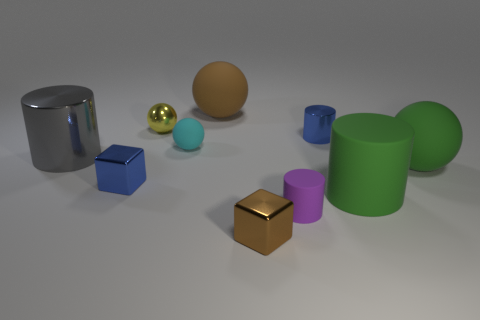Is the material of the small blue object left of the brown metallic block the same as the large brown thing?
Keep it short and to the point. No. What number of cubes are tiny matte objects or metal things?
Your answer should be compact. 2. What is the shape of the green object that is in front of the blue thing left of the brown object that is left of the small brown cube?
Make the answer very short. Cylinder. The object that is the same color as the big matte cylinder is what shape?
Your answer should be very brief. Sphere. What number of other balls have the same size as the cyan ball?
Keep it short and to the point. 1. Is there a green rubber cylinder right of the rubber cylinder that is on the right side of the purple thing?
Give a very brief answer. No. How many things are either tiny rubber cylinders or large yellow shiny balls?
Provide a succinct answer. 1. There is a large thing to the left of the blue thing that is on the left side of the metal cylinder that is on the right side of the blue cube; what color is it?
Offer a terse response. Gray. Are there any other things that have the same color as the small matte sphere?
Your answer should be very brief. No. Is the size of the green ball the same as the purple matte thing?
Ensure brevity in your answer.  No. 